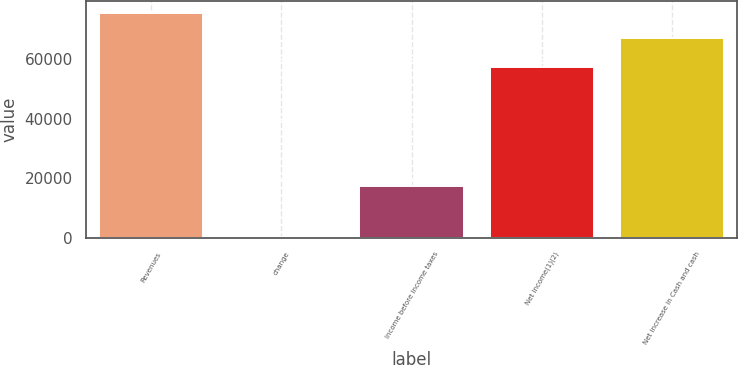<chart> <loc_0><loc_0><loc_500><loc_500><bar_chart><fcel>Revenues<fcel>change<fcel>Income before income taxes<fcel>Net income(1)(2)<fcel>Net increase in Cash and cash<nl><fcel>75797<fcel>29.7<fcel>17316<fcel>57587<fcel>67267<nl></chart> 